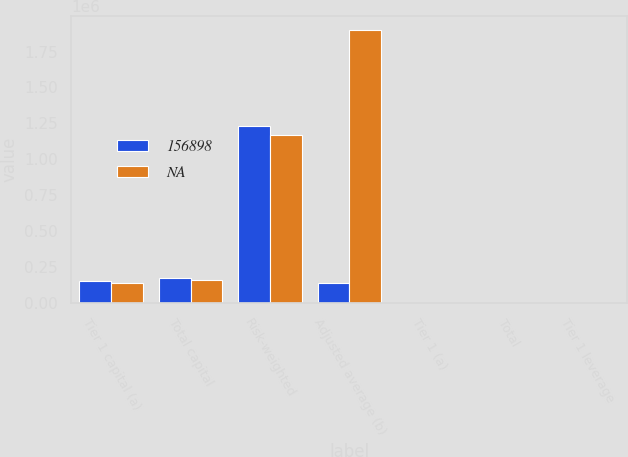<chart> <loc_0><loc_0><loc_500><loc_500><stacked_bar_chart><ecel><fcel>Tier 1 capital (a)<fcel>Total capital<fcel>Risk-weighted<fcel>Adjusted average (b)<fcel>Tier 1 (a)<fcel>Total<fcel>Tier 1 leverage<nl><fcel>156898<fcel>157222<fcel>173659<fcel>1.23036e+06<fcel>139727<fcel>12.8<fcel>14.1<fcel>8<nl><fcel>nan<fcel>139727<fcel>165496<fcel>1.17157e+06<fcel>1.90077e+06<fcel>11.9<fcel>14.1<fcel>7.4<nl></chart> 